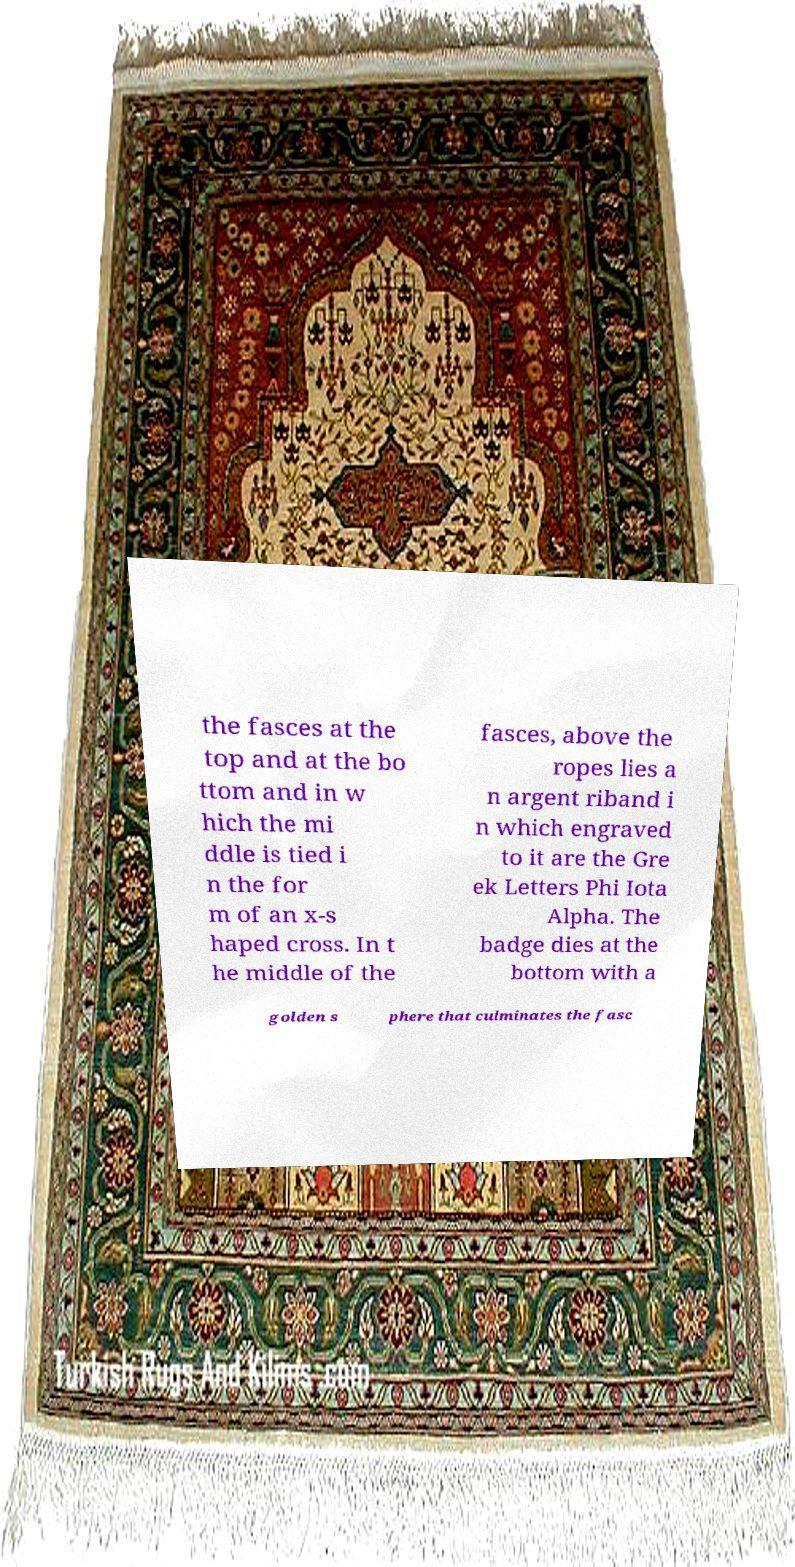Can you accurately transcribe the text from the provided image for me? the fasces at the top and at the bo ttom and in w hich the mi ddle is tied i n the for m of an x-s haped cross. In t he middle of the fasces, above the ropes lies a n argent riband i n which engraved to it are the Gre ek Letters Phi Iota Alpha. The badge dies at the bottom with a golden s phere that culminates the fasc 